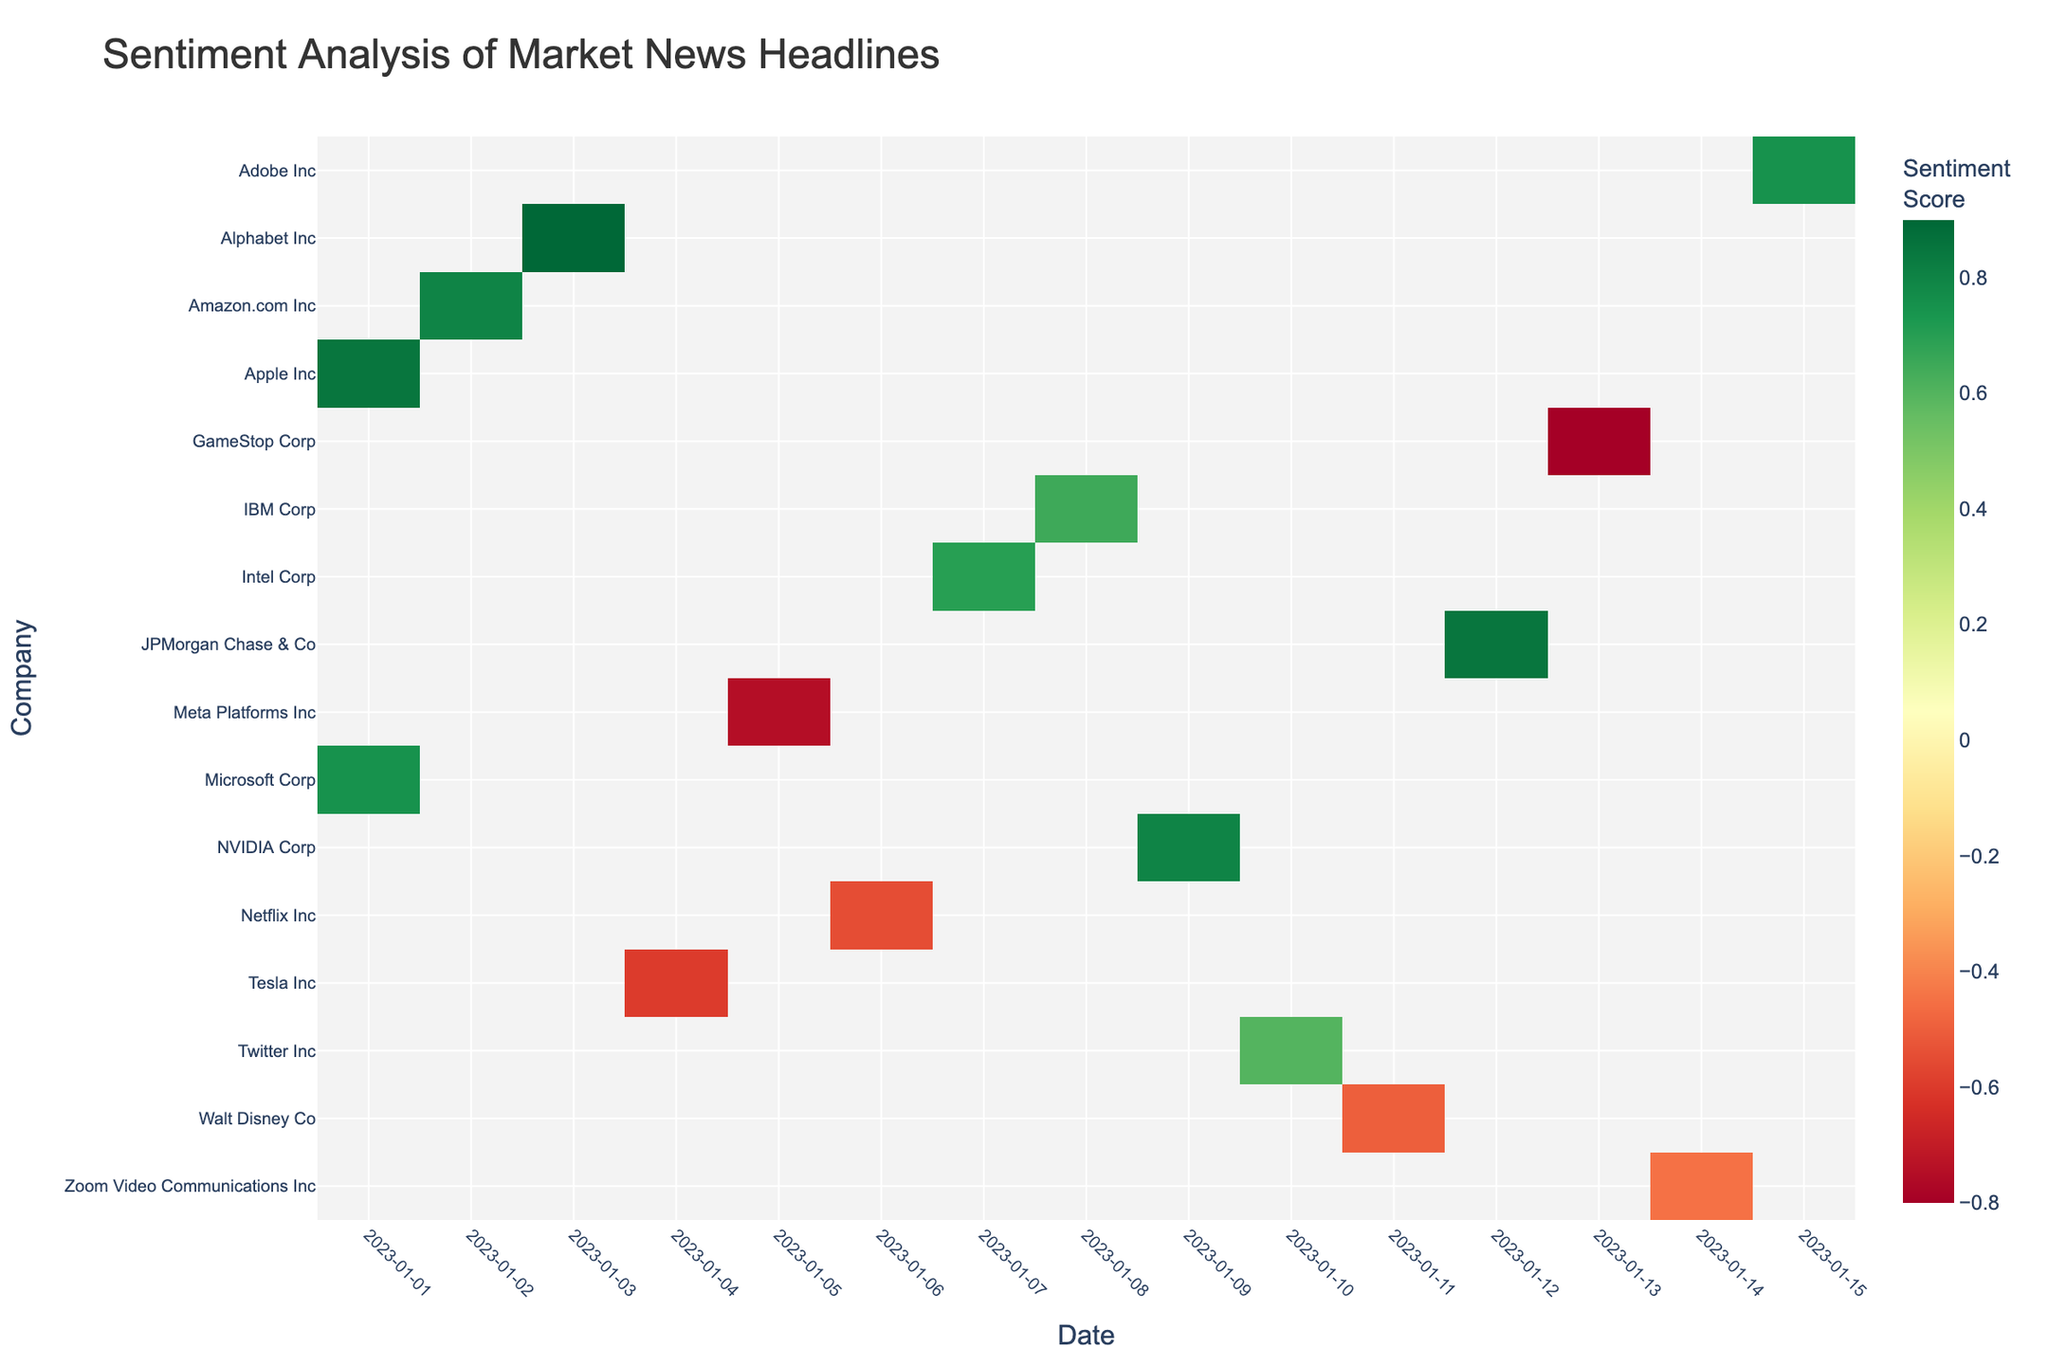What's the title of the heatmap? The title is usually at the top of the figure which provides a summary of what the heatmap is about. Here, it is clearly labeled.
Answer: Sentiment Analysis of Market News Headlines What does the green color on the heatmap indicate in terms of sentiment score? Colors in a heatmap represent different ranges of values. In this heatmap, the green color corresponds to higher positive sentiment scores as per the defined color scale (RdYlGn).
Answer: Positive sentiment score Which day shows the most negative sentiment for Tesla? By looking for the darkest red color in the Tesla row, we see that the most negative sentiment for Tesla is on January 4th.
Answer: January 4th How does the sentiment score trend look for Apple Inc over the given dates? By following the row corresponding to Apple Inc. and looking at the gradient of colors, we observe that it starts positively on January 1st. As Apple Inc had only one day with a news headline, there is no further trend but only one positive sentiment.
Answer: Positive start on January 1st Which companies had a negative sentiment score on January 11th? By examining the column for January 11th, we identify any red or negative colored cells. The cell for Disney on this date is in red, indicating a negative sentiment score.
Answer: Walt Disney Co What is the average sentiment score for Amazon.com Inc over the timeline? Amazon.com Inc only has one sentiment score for January 2nd, which is 0.80. Therefore, the average is simply this value.
Answer: 0.80 Which company has the highest overall sentiment score and on which date? By identifying the brightest green cell, we see that Google (Alphabet Inc) on January 3rd has the highest sentiment score.
Answer: Google (Alphabet Inc) on January 3rd Compare the sentiment scores of Microsoft Corp on January 1st and another company on January 1st. On January 1st, Microsoft Corp has a sentiment score of 0.75 while Apple Inc has a sentiment score of 0.85. Comparing these, Apple Inc has a higher score.
Answer: Apple Inc has a higher score on January 1st Which company showed an improvement in sentiment score from the start to the end of the period? By comparing the color gradient from earlier to later dates across rows, NVIDIA Corp shows improvement from a sentiment score on January 9th with a score of 0.80 (positive and green) which is high but remains the same across the period for January 9th, showing consistency.
Answer: NVIDIA Corp Do any companies have exactly neutral sentiment scores? A neutral sentiment score is marked by a value around 0. None of the cells in the heatmap are purely neutral shades or values that indicate around 0.
Answer: No 